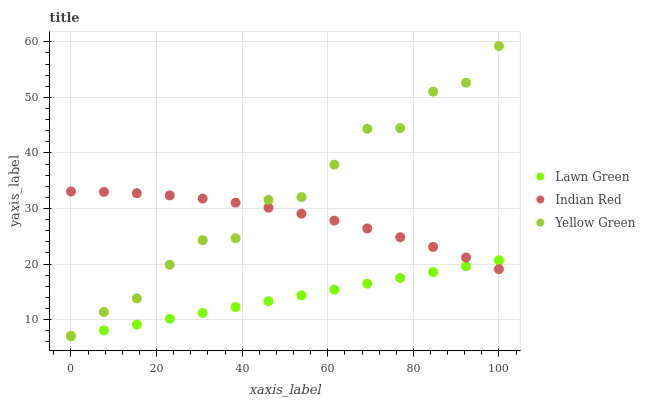Does Lawn Green have the minimum area under the curve?
Answer yes or no. Yes. Does Yellow Green have the maximum area under the curve?
Answer yes or no. Yes. Does Indian Red have the minimum area under the curve?
Answer yes or no. No. Does Indian Red have the maximum area under the curve?
Answer yes or no. No. Is Lawn Green the smoothest?
Answer yes or no. Yes. Is Yellow Green the roughest?
Answer yes or no. Yes. Is Indian Red the smoothest?
Answer yes or no. No. Is Indian Red the roughest?
Answer yes or no. No. Does Lawn Green have the lowest value?
Answer yes or no. Yes. Does Yellow Green have the lowest value?
Answer yes or no. No. Does Yellow Green have the highest value?
Answer yes or no. Yes. Does Indian Red have the highest value?
Answer yes or no. No. Is Lawn Green less than Yellow Green?
Answer yes or no. Yes. Is Yellow Green greater than Lawn Green?
Answer yes or no. Yes. Does Indian Red intersect Yellow Green?
Answer yes or no. Yes. Is Indian Red less than Yellow Green?
Answer yes or no. No. Is Indian Red greater than Yellow Green?
Answer yes or no. No. Does Lawn Green intersect Yellow Green?
Answer yes or no. No. 